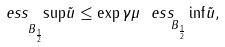Convert formula to latex. <formula><loc_0><loc_0><loc_500><loc_500>\underset { B _ { \frac { 1 } { 2 } } } { e s s \ \sup } \tilde { u } \leq \exp \gamma \mu \ \underset { B _ { \frac { 1 } { 2 } } } { e s s \ \inf } \tilde { u } ,</formula> 